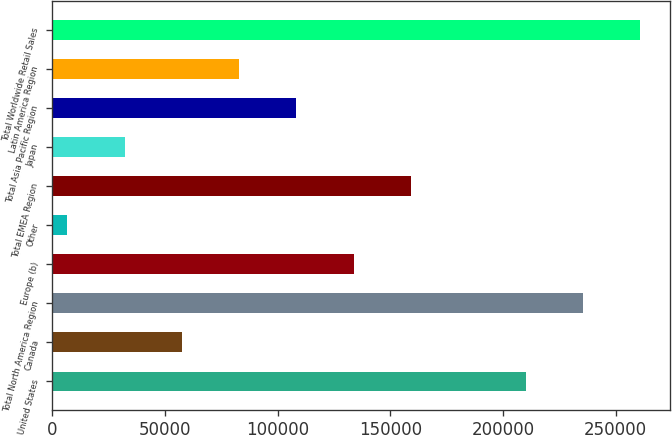Convert chart. <chart><loc_0><loc_0><loc_500><loc_500><bar_chart><fcel>United States<fcel>Canada<fcel>Total North America Region<fcel>Europe (b)<fcel>Other<fcel>Total EMEA Region<fcel>Japan<fcel>Total Asia Pacific Region<fcel>Latin America Region<fcel>Total Worldwide Retail Sales<nl><fcel>210008<fcel>57513.4<fcel>235423<fcel>133760<fcel>6682<fcel>159176<fcel>32097.7<fcel>108345<fcel>82929.1<fcel>260839<nl></chart> 